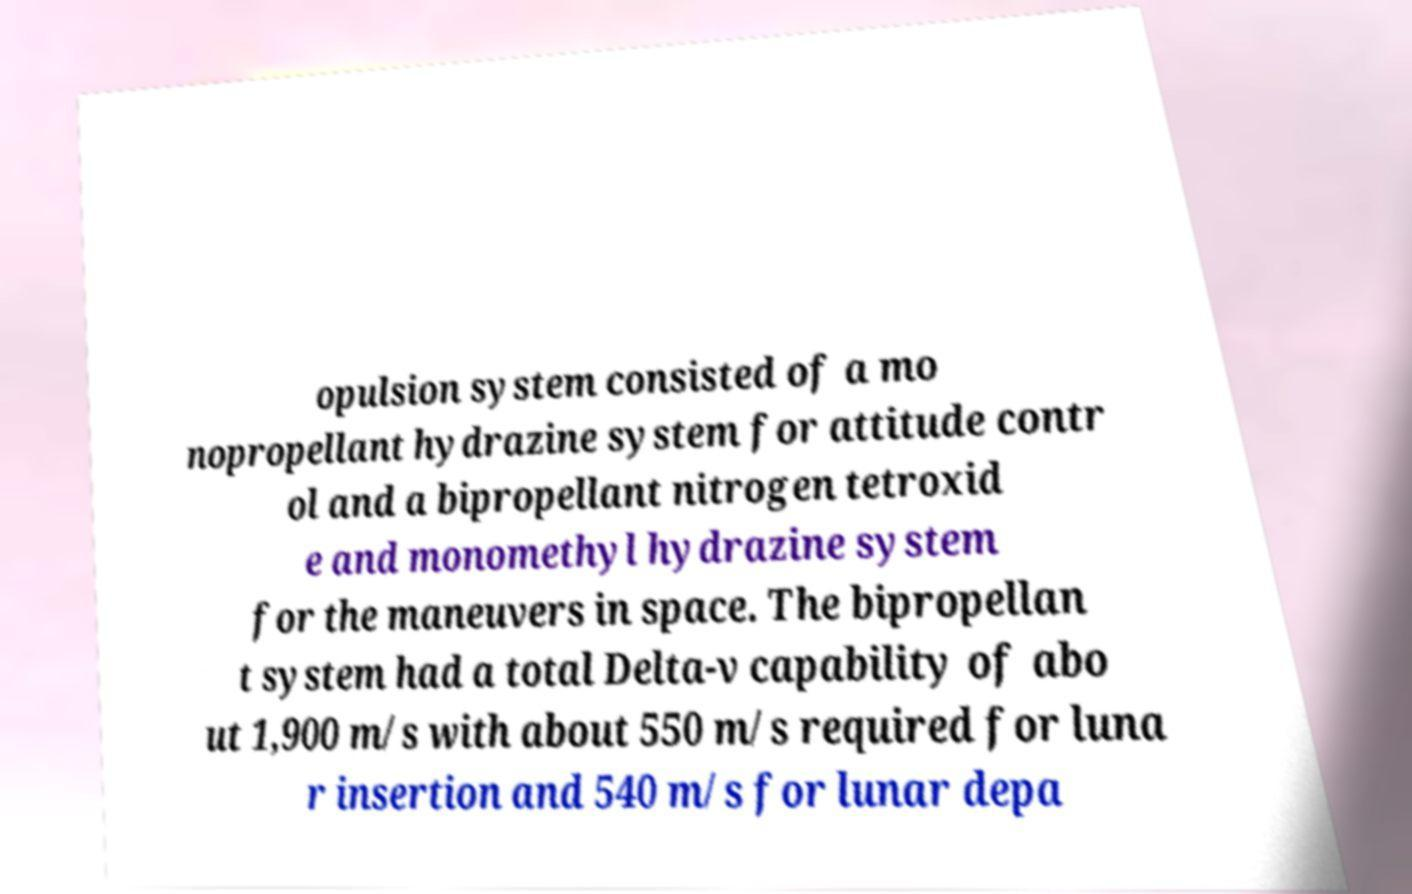Could you assist in decoding the text presented in this image and type it out clearly? opulsion system consisted of a mo nopropellant hydrazine system for attitude contr ol and a bipropellant nitrogen tetroxid e and monomethyl hydrazine system for the maneuvers in space. The bipropellan t system had a total Delta-v capability of abo ut 1,900 m/s with about 550 m/s required for luna r insertion and 540 m/s for lunar depa 